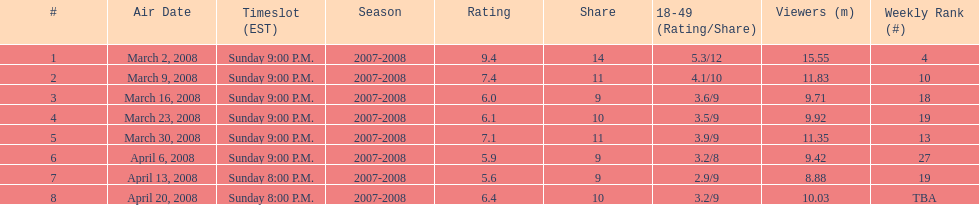How many programs managed to gather 10 million or more viewers? 4. 